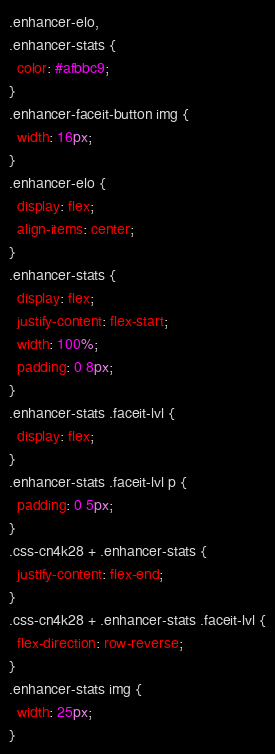Convert code to text. <code><loc_0><loc_0><loc_500><loc_500><_CSS_>.enhancer-elo,
.enhancer-stats {
  color: #afbbc9;
}
.enhancer-faceit-button img {
  width: 16px;
}
.enhancer-elo {
  display: flex;
  align-items: center;
}
.enhancer-stats {
  display: flex;
  justify-content: flex-start;
  width: 100%;
  padding: 0 8px;
}
.enhancer-stats .faceit-lvl {
  display: flex;
}
.enhancer-stats .faceit-lvl p {
  padding: 0 5px;
}
.css-cn4k28 + .enhancer-stats {
  justify-content: flex-end;
}
.css-cn4k28 + .enhancer-stats .faceit-lvl {
  flex-direction: row-reverse;
}
.enhancer-stats img {
  width: 25px;
}
</code> 